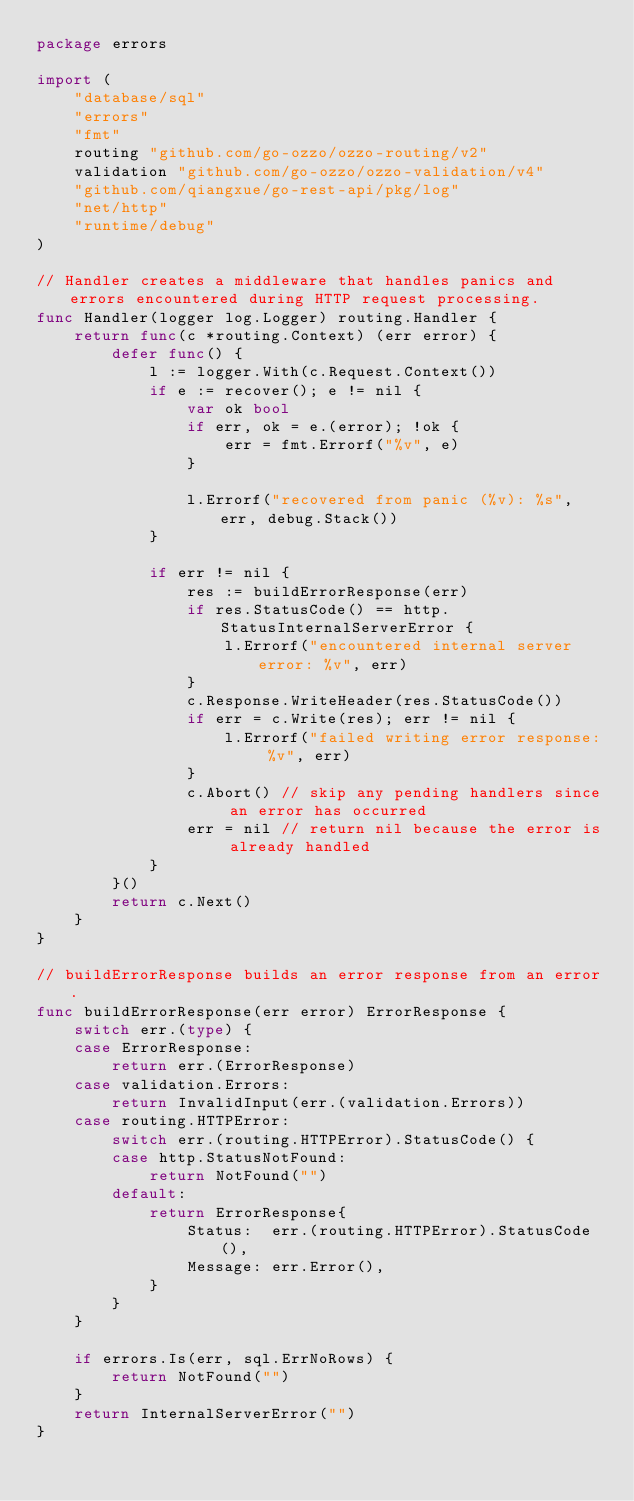<code> <loc_0><loc_0><loc_500><loc_500><_Go_>package errors

import (
	"database/sql"
	"errors"
	"fmt"
	routing "github.com/go-ozzo/ozzo-routing/v2"
	validation "github.com/go-ozzo/ozzo-validation/v4"
	"github.com/qiangxue/go-rest-api/pkg/log"
	"net/http"
	"runtime/debug"
)

// Handler creates a middleware that handles panics and errors encountered during HTTP request processing.
func Handler(logger log.Logger) routing.Handler {
	return func(c *routing.Context) (err error) {
		defer func() {
			l := logger.With(c.Request.Context())
			if e := recover(); e != nil {
				var ok bool
				if err, ok = e.(error); !ok {
					err = fmt.Errorf("%v", e)
				}

				l.Errorf("recovered from panic (%v): %s", err, debug.Stack())
			}

			if err != nil {
				res := buildErrorResponse(err)
				if res.StatusCode() == http.StatusInternalServerError {
					l.Errorf("encountered internal server error: %v", err)
				}
				c.Response.WriteHeader(res.StatusCode())
				if err = c.Write(res); err != nil {
					l.Errorf("failed writing error response: %v", err)
				}
				c.Abort() // skip any pending handlers since an error has occurred
				err = nil // return nil because the error is already handled
			}
		}()
		return c.Next()
	}
}

// buildErrorResponse builds an error response from an error.
func buildErrorResponse(err error) ErrorResponse {
	switch err.(type) {
	case ErrorResponse:
		return err.(ErrorResponse)
	case validation.Errors:
		return InvalidInput(err.(validation.Errors))
	case routing.HTTPError:
		switch err.(routing.HTTPError).StatusCode() {
		case http.StatusNotFound:
			return NotFound("")
		default:
			return ErrorResponse{
				Status:  err.(routing.HTTPError).StatusCode(),
				Message: err.Error(),
			}
		}
	}

	if errors.Is(err, sql.ErrNoRows) {
		return NotFound("")
	}
	return InternalServerError("")
}
</code> 